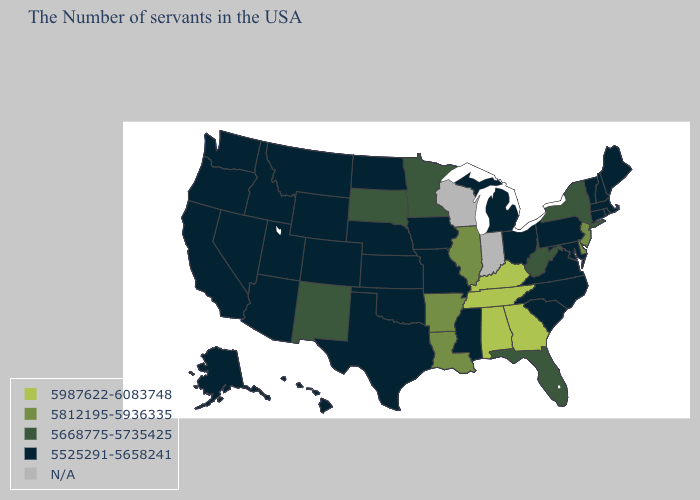What is the highest value in the USA?
Write a very short answer. 5987622-6083748. Does the map have missing data?
Write a very short answer. Yes. Among the states that border Texas , which have the highest value?
Give a very brief answer. Louisiana, Arkansas. Among the states that border Idaho , which have the highest value?
Write a very short answer. Wyoming, Utah, Montana, Nevada, Washington, Oregon. Name the states that have a value in the range 5525291-5658241?
Be succinct. Maine, Massachusetts, Rhode Island, New Hampshire, Vermont, Connecticut, Maryland, Pennsylvania, Virginia, North Carolina, South Carolina, Ohio, Michigan, Mississippi, Missouri, Iowa, Kansas, Nebraska, Oklahoma, Texas, North Dakota, Wyoming, Colorado, Utah, Montana, Arizona, Idaho, Nevada, California, Washington, Oregon, Alaska, Hawaii. Name the states that have a value in the range 5525291-5658241?
Answer briefly. Maine, Massachusetts, Rhode Island, New Hampshire, Vermont, Connecticut, Maryland, Pennsylvania, Virginia, North Carolina, South Carolina, Ohio, Michigan, Mississippi, Missouri, Iowa, Kansas, Nebraska, Oklahoma, Texas, North Dakota, Wyoming, Colorado, Utah, Montana, Arizona, Idaho, Nevada, California, Washington, Oregon, Alaska, Hawaii. What is the lowest value in the MidWest?
Quick response, please. 5525291-5658241. Which states have the lowest value in the USA?
Answer briefly. Maine, Massachusetts, Rhode Island, New Hampshire, Vermont, Connecticut, Maryland, Pennsylvania, Virginia, North Carolina, South Carolina, Ohio, Michigan, Mississippi, Missouri, Iowa, Kansas, Nebraska, Oklahoma, Texas, North Dakota, Wyoming, Colorado, Utah, Montana, Arizona, Idaho, Nevada, California, Washington, Oregon, Alaska, Hawaii. What is the value of Mississippi?
Answer briefly. 5525291-5658241. Among the states that border Vermont , which have the lowest value?
Write a very short answer. Massachusetts, New Hampshire. Among the states that border Nebraska , which have the highest value?
Keep it brief. South Dakota. Name the states that have a value in the range 5812195-5936335?
Quick response, please. New Jersey, Delaware, Illinois, Louisiana, Arkansas. Name the states that have a value in the range 5525291-5658241?
Be succinct. Maine, Massachusetts, Rhode Island, New Hampshire, Vermont, Connecticut, Maryland, Pennsylvania, Virginia, North Carolina, South Carolina, Ohio, Michigan, Mississippi, Missouri, Iowa, Kansas, Nebraska, Oklahoma, Texas, North Dakota, Wyoming, Colorado, Utah, Montana, Arizona, Idaho, Nevada, California, Washington, Oregon, Alaska, Hawaii. What is the value of West Virginia?
Keep it brief. 5668775-5735425. What is the value of Mississippi?
Answer briefly. 5525291-5658241. 